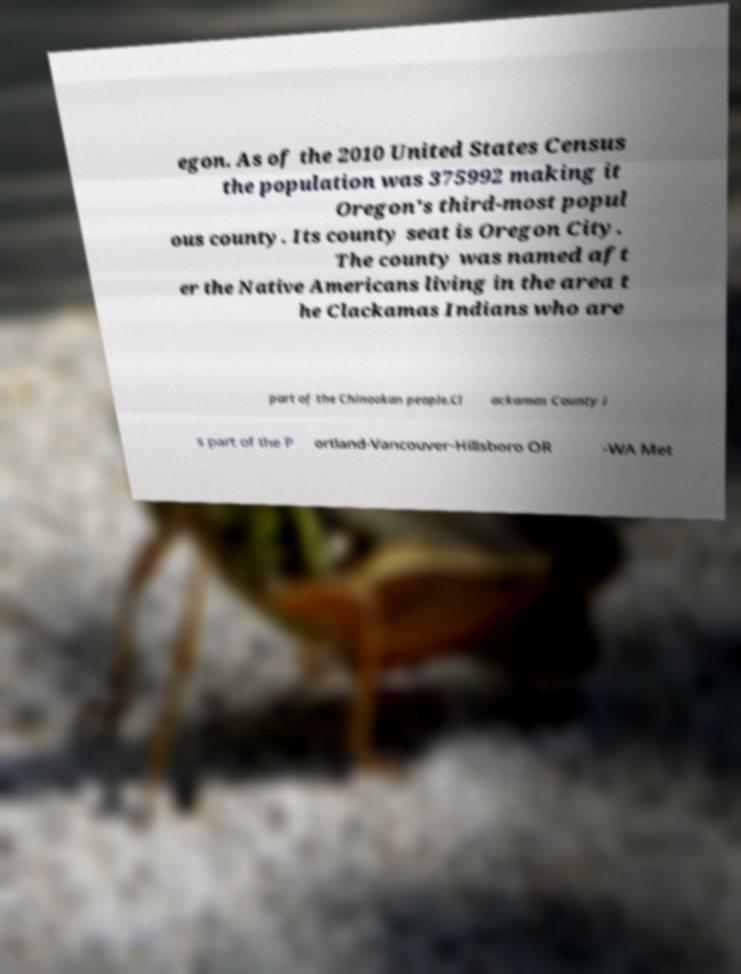Can you accurately transcribe the text from the provided image for me? egon. As of the 2010 United States Census the population was 375992 making it Oregon's third-most popul ous county. Its county seat is Oregon City. The county was named aft er the Native Americans living in the area t he Clackamas Indians who are part of the Chinookan people.Cl ackamas County i s part of the P ortland-Vancouver-Hillsboro OR -WA Met 